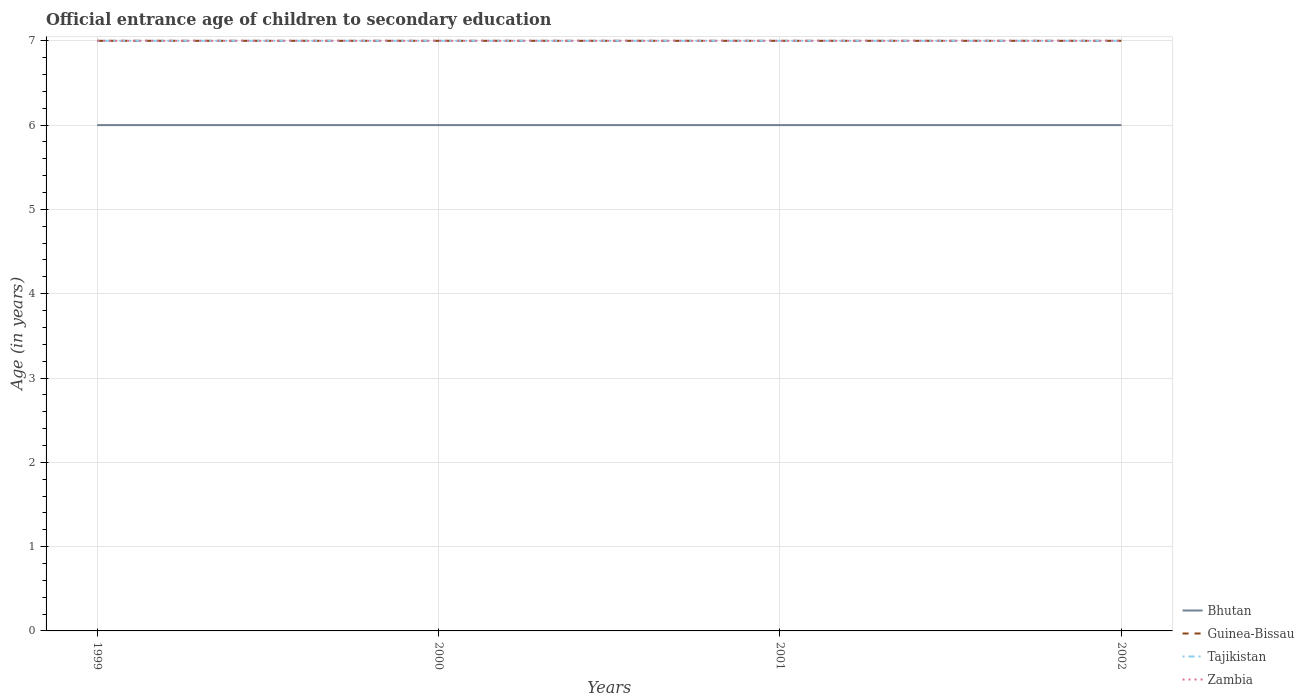How many different coloured lines are there?
Provide a short and direct response. 4. Across all years, what is the maximum secondary school starting age of children in Zambia?
Offer a terse response. 7. What is the total secondary school starting age of children in Bhutan in the graph?
Offer a very short reply. 0. What is the difference between the highest and the lowest secondary school starting age of children in Zambia?
Your response must be concise. 0. How many lines are there?
Ensure brevity in your answer.  4. How many years are there in the graph?
Ensure brevity in your answer.  4. Are the values on the major ticks of Y-axis written in scientific E-notation?
Provide a succinct answer. No. Does the graph contain any zero values?
Provide a short and direct response. No. Does the graph contain grids?
Provide a succinct answer. Yes. How many legend labels are there?
Provide a succinct answer. 4. How are the legend labels stacked?
Offer a very short reply. Vertical. What is the title of the graph?
Offer a very short reply. Official entrance age of children to secondary education. What is the label or title of the X-axis?
Give a very brief answer. Years. What is the label or title of the Y-axis?
Provide a short and direct response. Age (in years). What is the Age (in years) of Bhutan in 1999?
Keep it short and to the point. 6. What is the Age (in years) in Guinea-Bissau in 1999?
Your answer should be very brief. 7. What is the Age (in years) in Bhutan in 2000?
Provide a succinct answer. 6. What is the Age (in years) in Guinea-Bissau in 2000?
Ensure brevity in your answer.  7. What is the Age (in years) in Tajikistan in 2001?
Make the answer very short. 7. What is the Age (in years) of Zambia in 2001?
Offer a very short reply. 7. What is the Age (in years) of Guinea-Bissau in 2002?
Ensure brevity in your answer.  7. What is the Age (in years) of Tajikistan in 2002?
Provide a succinct answer. 7. Across all years, what is the maximum Age (in years) in Guinea-Bissau?
Offer a very short reply. 7. Across all years, what is the minimum Age (in years) of Bhutan?
Provide a short and direct response. 6. Across all years, what is the minimum Age (in years) in Tajikistan?
Ensure brevity in your answer.  7. What is the total Age (in years) of Guinea-Bissau in the graph?
Provide a short and direct response. 28. What is the total Age (in years) in Tajikistan in the graph?
Keep it short and to the point. 28. What is the total Age (in years) of Zambia in the graph?
Your answer should be compact. 28. What is the difference between the Age (in years) of Guinea-Bissau in 1999 and that in 2000?
Provide a short and direct response. 0. What is the difference between the Age (in years) in Tajikistan in 1999 and that in 2000?
Give a very brief answer. 0. What is the difference between the Age (in years) of Guinea-Bissau in 1999 and that in 2001?
Your answer should be very brief. 0. What is the difference between the Age (in years) of Tajikistan in 1999 and that in 2001?
Your answer should be compact. 0. What is the difference between the Age (in years) of Bhutan in 1999 and that in 2002?
Give a very brief answer. 0. What is the difference between the Age (in years) in Zambia in 1999 and that in 2002?
Your response must be concise. 0. What is the difference between the Age (in years) of Bhutan in 2000 and that in 2001?
Your answer should be very brief. 0. What is the difference between the Age (in years) of Guinea-Bissau in 2000 and that in 2001?
Offer a very short reply. 0. What is the difference between the Age (in years) in Tajikistan in 2000 and that in 2001?
Offer a terse response. 0. What is the difference between the Age (in years) in Tajikistan in 2000 and that in 2002?
Keep it short and to the point. 0. What is the difference between the Age (in years) in Zambia in 2000 and that in 2002?
Offer a terse response. 0. What is the difference between the Age (in years) in Bhutan in 2001 and that in 2002?
Offer a terse response. 0. What is the difference between the Age (in years) of Guinea-Bissau in 2001 and that in 2002?
Give a very brief answer. 0. What is the difference between the Age (in years) of Bhutan in 1999 and the Age (in years) of Guinea-Bissau in 2000?
Provide a succinct answer. -1. What is the difference between the Age (in years) of Bhutan in 1999 and the Age (in years) of Zambia in 2000?
Offer a very short reply. -1. What is the difference between the Age (in years) of Guinea-Bissau in 1999 and the Age (in years) of Zambia in 2000?
Offer a terse response. 0. What is the difference between the Age (in years) of Bhutan in 1999 and the Age (in years) of Guinea-Bissau in 2001?
Your answer should be very brief. -1. What is the difference between the Age (in years) of Bhutan in 1999 and the Age (in years) of Zambia in 2001?
Offer a terse response. -1. What is the difference between the Age (in years) in Guinea-Bissau in 1999 and the Age (in years) in Tajikistan in 2001?
Make the answer very short. 0. What is the difference between the Age (in years) in Guinea-Bissau in 1999 and the Age (in years) in Zambia in 2001?
Give a very brief answer. 0. What is the difference between the Age (in years) in Bhutan in 1999 and the Age (in years) in Guinea-Bissau in 2002?
Your response must be concise. -1. What is the difference between the Age (in years) in Bhutan in 1999 and the Age (in years) in Tajikistan in 2002?
Offer a very short reply. -1. What is the difference between the Age (in years) of Guinea-Bissau in 1999 and the Age (in years) of Zambia in 2002?
Give a very brief answer. 0. What is the difference between the Age (in years) of Bhutan in 2000 and the Age (in years) of Guinea-Bissau in 2001?
Offer a terse response. -1. What is the difference between the Age (in years) of Bhutan in 2000 and the Age (in years) of Tajikistan in 2001?
Give a very brief answer. -1. What is the difference between the Age (in years) in Guinea-Bissau in 2000 and the Age (in years) in Zambia in 2001?
Keep it short and to the point. 0. What is the difference between the Age (in years) of Tajikistan in 2000 and the Age (in years) of Zambia in 2001?
Your response must be concise. 0. What is the difference between the Age (in years) in Bhutan in 2000 and the Age (in years) in Guinea-Bissau in 2002?
Your answer should be compact. -1. What is the difference between the Age (in years) of Bhutan in 2000 and the Age (in years) of Tajikistan in 2002?
Ensure brevity in your answer.  -1. What is the difference between the Age (in years) in Tajikistan in 2000 and the Age (in years) in Zambia in 2002?
Ensure brevity in your answer.  0. What is the difference between the Age (in years) in Tajikistan in 2001 and the Age (in years) in Zambia in 2002?
Keep it short and to the point. 0. What is the average Age (in years) in Bhutan per year?
Your answer should be compact. 6. What is the average Age (in years) of Guinea-Bissau per year?
Your answer should be very brief. 7. What is the average Age (in years) in Tajikistan per year?
Your response must be concise. 7. What is the average Age (in years) in Zambia per year?
Ensure brevity in your answer.  7. In the year 1999, what is the difference between the Age (in years) of Bhutan and Age (in years) of Tajikistan?
Ensure brevity in your answer.  -1. In the year 1999, what is the difference between the Age (in years) of Guinea-Bissau and Age (in years) of Tajikistan?
Provide a succinct answer. 0. In the year 1999, what is the difference between the Age (in years) of Guinea-Bissau and Age (in years) of Zambia?
Make the answer very short. 0. In the year 1999, what is the difference between the Age (in years) in Tajikistan and Age (in years) in Zambia?
Give a very brief answer. 0. In the year 2000, what is the difference between the Age (in years) in Bhutan and Age (in years) in Guinea-Bissau?
Keep it short and to the point. -1. In the year 2000, what is the difference between the Age (in years) in Bhutan and Age (in years) in Tajikistan?
Offer a very short reply. -1. In the year 2000, what is the difference between the Age (in years) of Bhutan and Age (in years) of Zambia?
Make the answer very short. -1. In the year 2000, what is the difference between the Age (in years) in Guinea-Bissau and Age (in years) in Tajikistan?
Provide a short and direct response. 0. In the year 2000, what is the difference between the Age (in years) of Guinea-Bissau and Age (in years) of Zambia?
Your answer should be compact. 0. In the year 2000, what is the difference between the Age (in years) of Tajikistan and Age (in years) of Zambia?
Offer a terse response. 0. In the year 2001, what is the difference between the Age (in years) in Bhutan and Age (in years) in Tajikistan?
Offer a very short reply. -1. In the year 2001, what is the difference between the Age (in years) in Guinea-Bissau and Age (in years) in Zambia?
Give a very brief answer. 0. In the year 2001, what is the difference between the Age (in years) of Tajikistan and Age (in years) of Zambia?
Provide a succinct answer. 0. In the year 2002, what is the difference between the Age (in years) of Bhutan and Age (in years) of Guinea-Bissau?
Provide a short and direct response. -1. In the year 2002, what is the difference between the Age (in years) in Bhutan and Age (in years) in Tajikistan?
Offer a terse response. -1. In the year 2002, what is the difference between the Age (in years) in Bhutan and Age (in years) in Zambia?
Your answer should be compact. -1. In the year 2002, what is the difference between the Age (in years) of Tajikistan and Age (in years) of Zambia?
Ensure brevity in your answer.  0. What is the ratio of the Age (in years) in Bhutan in 1999 to that in 2000?
Provide a short and direct response. 1. What is the ratio of the Age (in years) of Guinea-Bissau in 1999 to that in 2000?
Provide a short and direct response. 1. What is the ratio of the Age (in years) of Tajikistan in 1999 to that in 2000?
Your response must be concise. 1. What is the ratio of the Age (in years) of Bhutan in 1999 to that in 2001?
Your answer should be very brief. 1. What is the ratio of the Age (in years) in Zambia in 1999 to that in 2001?
Ensure brevity in your answer.  1. What is the ratio of the Age (in years) in Bhutan in 1999 to that in 2002?
Provide a short and direct response. 1. What is the ratio of the Age (in years) in Bhutan in 2000 to that in 2001?
Offer a very short reply. 1. What is the ratio of the Age (in years) in Tajikistan in 2000 to that in 2001?
Give a very brief answer. 1. What is the ratio of the Age (in years) in Bhutan in 2000 to that in 2002?
Your answer should be very brief. 1. What is the ratio of the Age (in years) of Guinea-Bissau in 2000 to that in 2002?
Offer a very short reply. 1. What is the ratio of the Age (in years) of Tajikistan in 2000 to that in 2002?
Provide a short and direct response. 1. What is the ratio of the Age (in years) of Zambia in 2000 to that in 2002?
Keep it short and to the point. 1. What is the ratio of the Age (in years) of Tajikistan in 2001 to that in 2002?
Give a very brief answer. 1. What is the difference between the highest and the second highest Age (in years) of Guinea-Bissau?
Your response must be concise. 0. What is the difference between the highest and the second highest Age (in years) in Tajikistan?
Give a very brief answer. 0. What is the difference between the highest and the second highest Age (in years) of Zambia?
Keep it short and to the point. 0. 